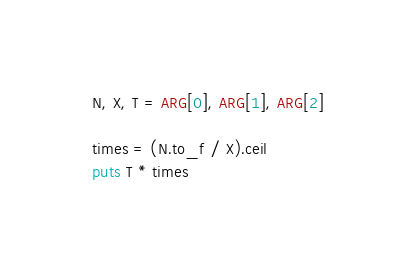Convert code to text. <code><loc_0><loc_0><loc_500><loc_500><_Ruby_>N, X, T = ARG[0], ARG[1], ARG[2]

times = (N.to_f / X).ceil
puts T * times</code> 